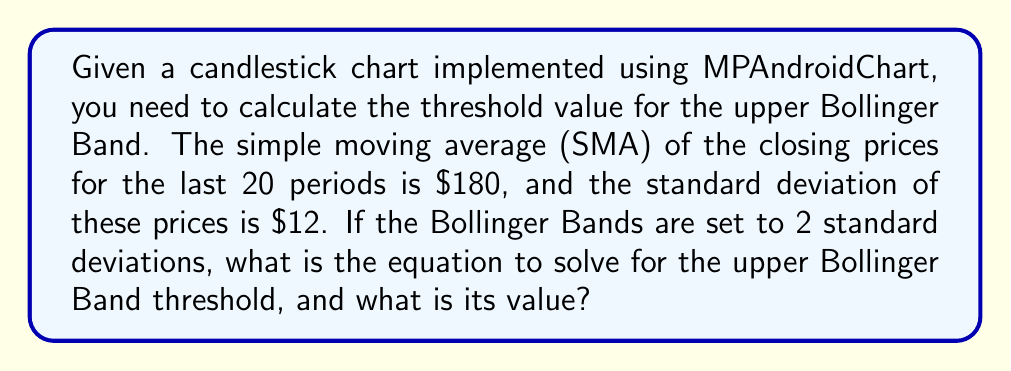Provide a solution to this math problem. To solve this problem, we'll follow these steps:

1. Recall the formula for the upper Bollinger Band:
   $$\text{Upper BB} = \text{SMA} + (k \times \sigma)$$
   Where:
   - SMA is the Simple Moving Average
   - k is the number of standard deviations (typically 2)
   - σ (sigma) is the standard deviation of the prices

2. We're given the following values:
   - SMA = $180
   - σ = $12
   - k = 2 (as stated in the question)

3. Let's substitute these values into the formula:
   $$\text{Upper BB} = 180 + (2 \times 12)$$

4. Simplify the multiplication inside the parentheses:
   $$\text{Upper BB} = 180 + 24$$

5. Perform the addition:
   $$\text{Upper BB} = 204$$

Therefore, the equation to solve for the upper Bollinger Band threshold is:
$$180 + (2 \times 12) = 204$$

And the value of the upper Bollinger Band threshold is $204.
Answer: $204 